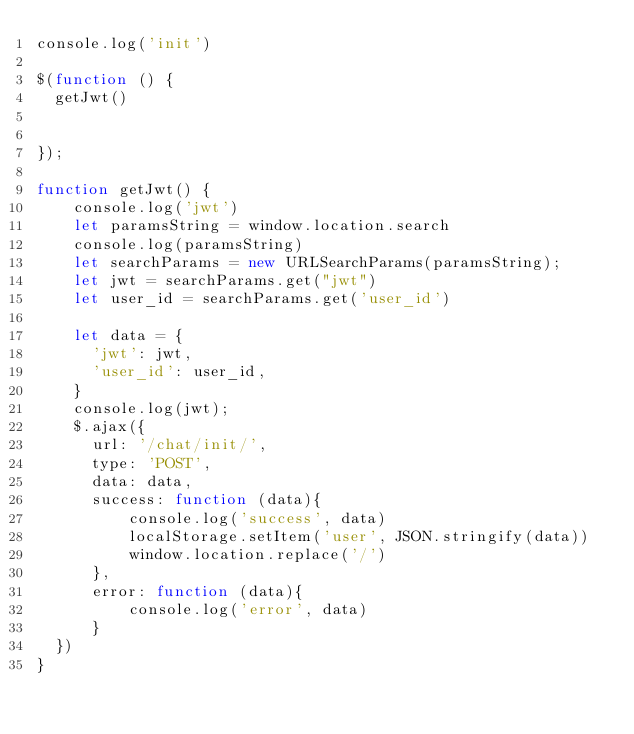<code> <loc_0><loc_0><loc_500><loc_500><_JavaScript_>console.log('init')

$(function () {
  getJwt()


});

function getJwt() {
    console.log('jwt')
    let paramsString = window.location.search
    console.log(paramsString)
    let searchParams = new URLSearchParams(paramsString);
    let jwt = searchParams.get("jwt")
    let user_id = searchParams.get('user_id')

    let data = {
      'jwt': jwt,
      'user_id': user_id,
    }
    console.log(jwt);
    $.ajax({
      url: '/chat/init/',
      type: 'POST',
      data: data,
      success: function (data){
          console.log('success', data)
          localStorage.setItem('user', JSON.stringify(data))
          window.location.replace('/')
      },
      error: function (data){
          console.log('error', data)
      }
  })
}

</code> 